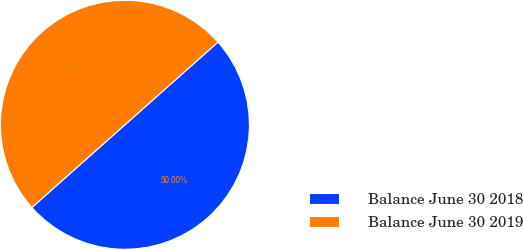<chart> <loc_0><loc_0><loc_500><loc_500><pie_chart><fcel>Balance June 30 2018<fcel>Balance June 30 2019<nl><fcel>50.0%<fcel>50.0%<nl></chart> 